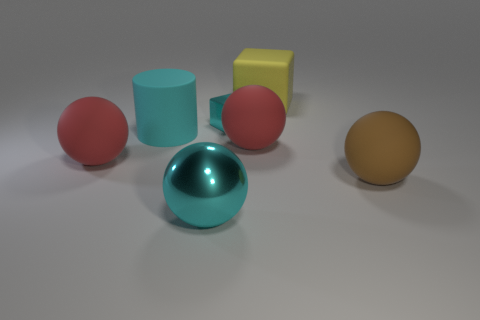Are there any large blocks made of the same material as the tiny cyan block?
Offer a terse response. No. How many rubber things are either blue cylinders or blocks?
Your answer should be compact. 1. There is a cyan metallic thing behind the red sphere that is to the right of the cyan cylinder; what is its shape?
Keep it short and to the point. Cube. Are there fewer large rubber cubes that are behind the large cube than big yellow rubber cubes?
Make the answer very short. Yes. There is a big brown object; what shape is it?
Provide a short and direct response. Sphere. There is a block in front of the yellow rubber cube; how big is it?
Keep it short and to the point. Small. The cylinder that is the same size as the shiny sphere is what color?
Your answer should be very brief. Cyan. Is there a large sphere that has the same color as the small metal thing?
Provide a short and direct response. Yes. Is the number of big brown spheres that are to the left of the big cyan rubber cylinder less than the number of large red matte objects that are on the right side of the metallic cube?
Give a very brief answer. Yes. There is a cyan object that is both to the right of the cyan cylinder and in front of the small cyan metal thing; what is its material?
Offer a very short reply. Metal. 